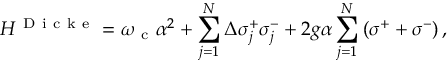<formula> <loc_0><loc_0><loc_500><loc_500>H ^ { D i c k e } = \omega _ { c } \alpha ^ { 2 } + \sum _ { j = 1 } ^ { N } \Delta \sigma _ { j } ^ { + } \sigma _ { j } ^ { - } + 2 g \alpha \sum _ { j = 1 } ^ { N } \left ( \sigma ^ { + } + \sigma ^ { - } \right ) ,</formula> 